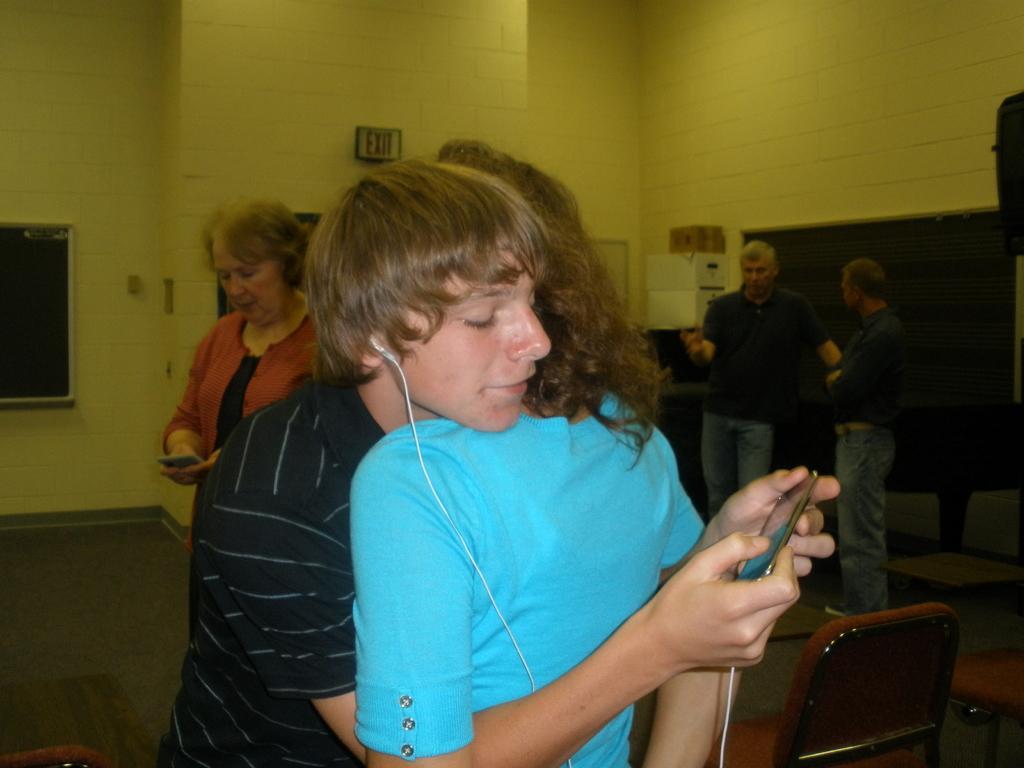In one or two sentences, can you explain what this image depicts? This picture describes about group of people, in the middle of the image a man is wearing earphones and he is holding mobile in his hands, in the background we can see couple of boxes, a wall and a notice board. 